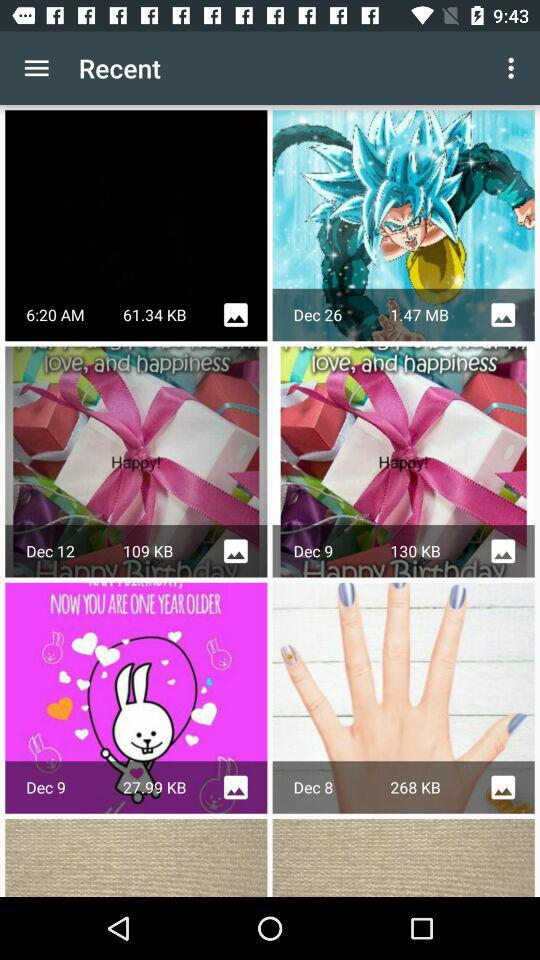What is the size of the image taken on December 26? The size of the image taken on December 26 is 1.47 MB. 